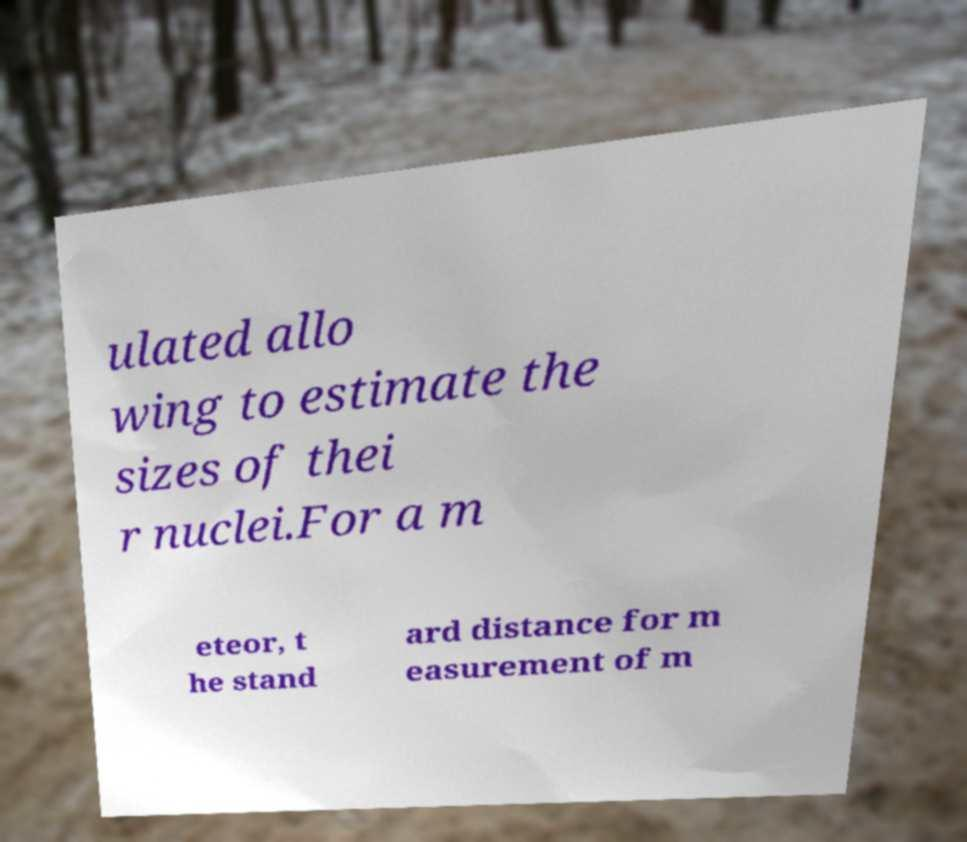I need the written content from this picture converted into text. Can you do that? ulated allo wing to estimate the sizes of thei r nuclei.For a m eteor, t he stand ard distance for m easurement of m 